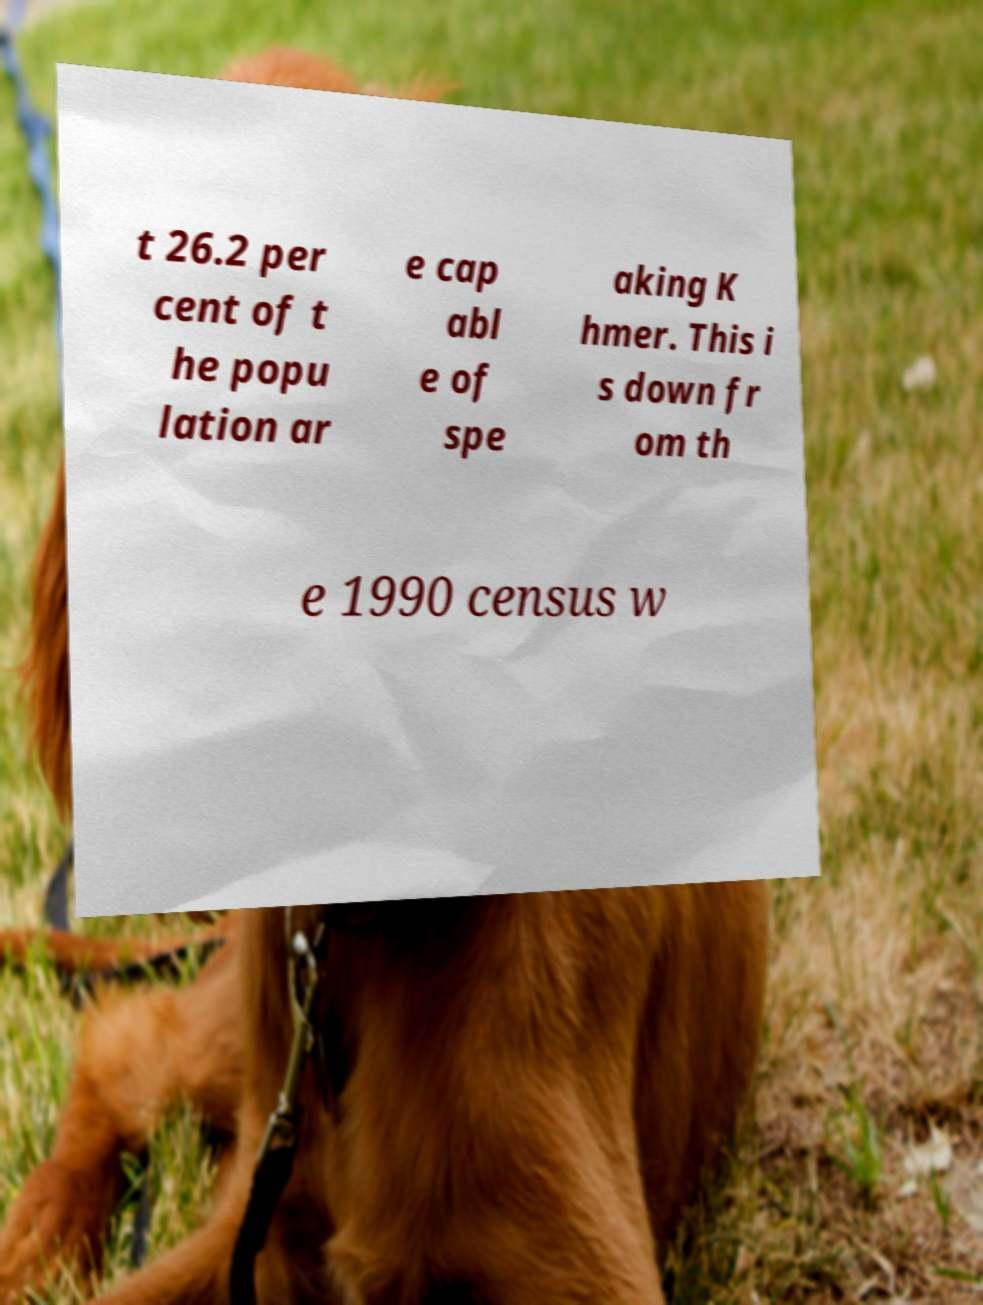Could you assist in decoding the text presented in this image and type it out clearly? t 26.2 per cent of t he popu lation ar e cap abl e of spe aking K hmer. This i s down fr om th e 1990 census w 